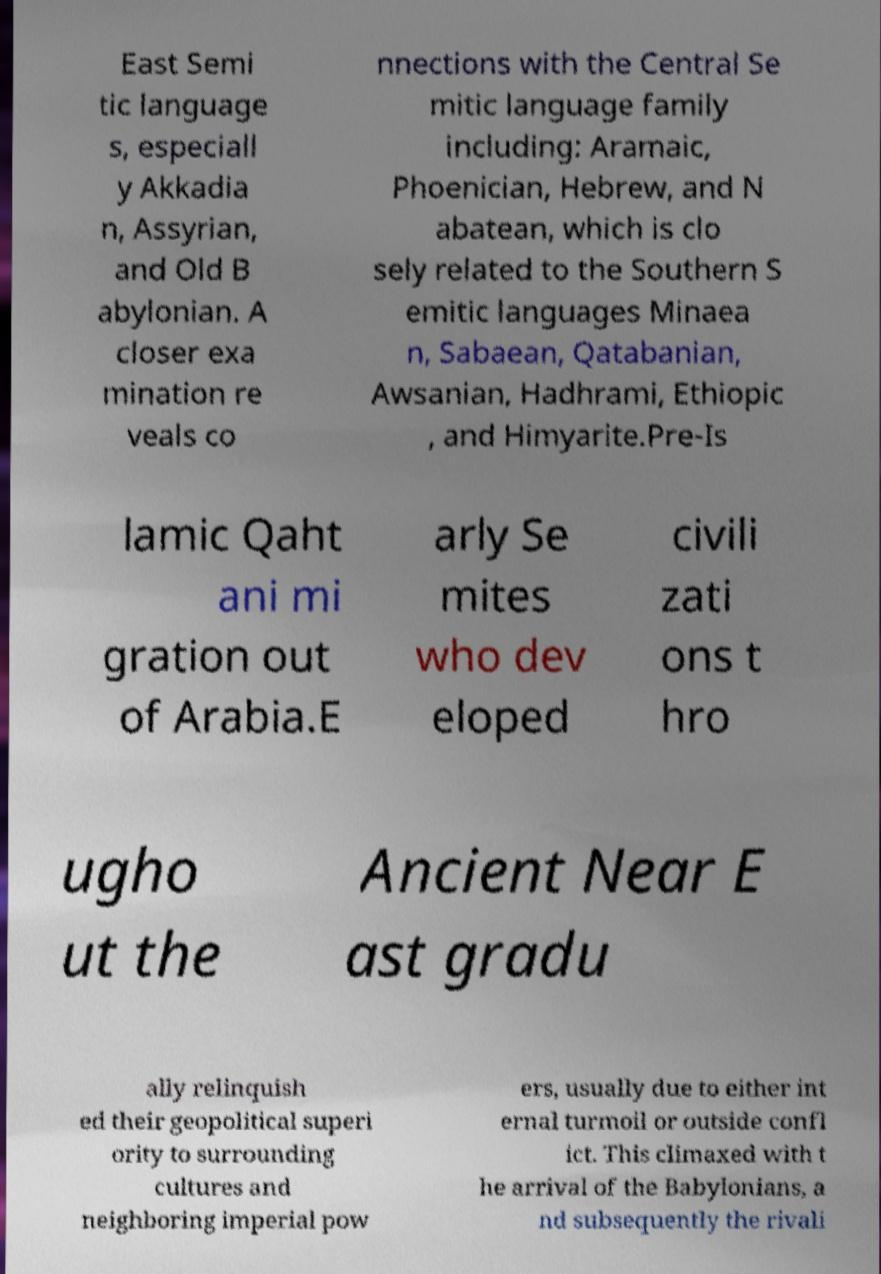There's text embedded in this image that I need extracted. Can you transcribe it verbatim? East Semi tic language s, especiall y Akkadia n, Assyrian, and Old B abylonian. A closer exa mination re veals co nnections with the Central Se mitic language family including: Aramaic, Phoenician, Hebrew, and N abatean, which is clo sely related to the Southern S emitic languages Minaea n, Sabaean, Qatabanian, Awsanian, Hadhrami, Ethiopic , and Himyarite.Pre-Is lamic Qaht ani mi gration out of Arabia.E arly Se mites who dev eloped civili zati ons t hro ugho ut the Ancient Near E ast gradu ally relinquish ed their geopolitical superi ority to surrounding cultures and neighboring imperial pow ers, usually due to either int ernal turmoil or outside confl ict. This climaxed with t he arrival of the Babylonians, a nd subsequently the rivali 